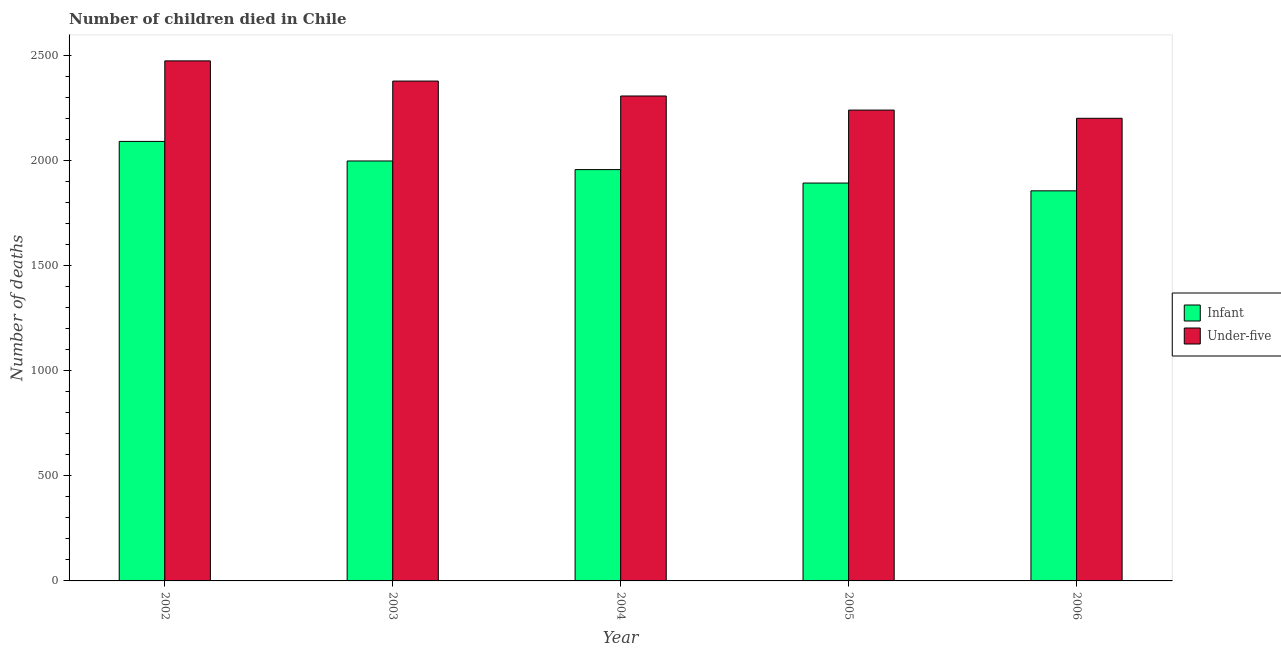How many different coloured bars are there?
Give a very brief answer. 2. Are the number of bars per tick equal to the number of legend labels?
Your answer should be compact. Yes. How many bars are there on the 5th tick from the left?
Your answer should be compact. 2. How many bars are there on the 4th tick from the right?
Ensure brevity in your answer.  2. In how many cases, is the number of bars for a given year not equal to the number of legend labels?
Provide a short and direct response. 0. What is the number of infant deaths in 2002?
Provide a short and direct response. 2090. Across all years, what is the maximum number of infant deaths?
Your answer should be compact. 2090. Across all years, what is the minimum number of under-five deaths?
Offer a terse response. 2200. In which year was the number of under-five deaths maximum?
Give a very brief answer. 2002. In which year was the number of infant deaths minimum?
Your response must be concise. 2006. What is the total number of infant deaths in the graph?
Your answer should be compact. 9790. What is the difference between the number of infant deaths in 2004 and that in 2006?
Your answer should be compact. 101. What is the difference between the number of under-five deaths in 2003 and the number of infant deaths in 2004?
Your answer should be compact. 71. What is the average number of under-five deaths per year?
Your response must be concise. 2319. In the year 2006, what is the difference between the number of under-five deaths and number of infant deaths?
Keep it short and to the point. 0. What is the ratio of the number of infant deaths in 2002 to that in 2004?
Provide a short and direct response. 1.07. Is the number of infant deaths in 2003 less than that in 2005?
Your response must be concise. No. Is the difference between the number of under-five deaths in 2002 and 2005 greater than the difference between the number of infant deaths in 2002 and 2005?
Your answer should be very brief. No. What is the difference between the highest and the second highest number of infant deaths?
Make the answer very short. 93. What is the difference between the highest and the lowest number of under-five deaths?
Offer a terse response. 273. In how many years, is the number of under-five deaths greater than the average number of under-five deaths taken over all years?
Provide a short and direct response. 2. Is the sum of the number of under-five deaths in 2003 and 2004 greater than the maximum number of infant deaths across all years?
Offer a terse response. Yes. What does the 2nd bar from the left in 2002 represents?
Make the answer very short. Under-five. What does the 2nd bar from the right in 2004 represents?
Offer a very short reply. Infant. How many bars are there?
Your answer should be very brief. 10. Are all the bars in the graph horizontal?
Your answer should be compact. No. How many years are there in the graph?
Offer a very short reply. 5. Does the graph contain grids?
Keep it short and to the point. No. Where does the legend appear in the graph?
Give a very brief answer. Center right. What is the title of the graph?
Your answer should be very brief. Number of children died in Chile. What is the label or title of the X-axis?
Offer a very short reply. Year. What is the label or title of the Y-axis?
Give a very brief answer. Number of deaths. What is the Number of deaths of Infant in 2002?
Provide a succinct answer. 2090. What is the Number of deaths of Under-five in 2002?
Make the answer very short. 2473. What is the Number of deaths in Infant in 2003?
Your answer should be compact. 1997. What is the Number of deaths in Under-five in 2003?
Your response must be concise. 2377. What is the Number of deaths in Infant in 2004?
Your answer should be compact. 1956. What is the Number of deaths in Under-five in 2004?
Provide a short and direct response. 2306. What is the Number of deaths in Infant in 2005?
Provide a short and direct response. 1892. What is the Number of deaths of Under-five in 2005?
Keep it short and to the point. 2239. What is the Number of deaths of Infant in 2006?
Provide a succinct answer. 1855. What is the Number of deaths in Under-five in 2006?
Offer a very short reply. 2200. Across all years, what is the maximum Number of deaths in Infant?
Keep it short and to the point. 2090. Across all years, what is the maximum Number of deaths of Under-five?
Keep it short and to the point. 2473. Across all years, what is the minimum Number of deaths in Infant?
Your answer should be very brief. 1855. Across all years, what is the minimum Number of deaths in Under-five?
Your answer should be very brief. 2200. What is the total Number of deaths in Infant in the graph?
Your response must be concise. 9790. What is the total Number of deaths in Under-five in the graph?
Keep it short and to the point. 1.16e+04. What is the difference between the Number of deaths in Infant in 2002 and that in 2003?
Ensure brevity in your answer.  93. What is the difference between the Number of deaths in Under-five in 2002 and that in 2003?
Offer a terse response. 96. What is the difference between the Number of deaths in Infant in 2002 and that in 2004?
Offer a terse response. 134. What is the difference between the Number of deaths of Under-five in 2002 and that in 2004?
Your response must be concise. 167. What is the difference between the Number of deaths of Infant in 2002 and that in 2005?
Keep it short and to the point. 198. What is the difference between the Number of deaths in Under-five in 2002 and that in 2005?
Offer a terse response. 234. What is the difference between the Number of deaths of Infant in 2002 and that in 2006?
Keep it short and to the point. 235. What is the difference between the Number of deaths in Under-five in 2002 and that in 2006?
Your answer should be very brief. 273. What is the difference between the Number of deaths of Infant in 2003 and that in 2004?
Offer a terse response. 41. What is the difference between the Number of deaths of Infant in 2003 and that in 2005?
Your answer should be compact. 105. What is the difference between the Number of deaths of Under-five in 2003 and that in 2005?
Keep it short and to the point. 138. What is the difference between the Number of deaths of Infant in 2003 and that in 2006?
Keep it short and to the point. 142. What is the difference between the Number of deaths in Under-five in 2003 and that in 2006?
Your answer should be very brief. 177. What is the difference between the Number of deaths in Infant in 2004 and that in 2006?
Make the answer very short. 101. What is the difference between the Number of deaths of Under-five in 2004 and that in 2006?
Provide a succinct answer. 106. What is the difference between the Number of deaths of Infant in 2005 and that in 2006?
Offer a terse response. 37. What is the difference between the Number of deaths of Infant in 2002 and the Number of deaths of Under-five in 2003?
Your answer should be compact. -287. What is the difference between the Number of deaths in Infant in 2002 and the Number of deaths in Under-five in 2004?
Your answer should be very brief. -216. What is the difference between the Number of deaths of Infant in 2002 and the Number of deaths of Under-five in 2005?
Provide a short and direct response. -149. What is the difference between the Number of deaths in Infant in 2002 and the Number of deaths in Under-five in 2006?
Your answer should be very brief. -110. What is the difference between the Number of deaths of Infant in 2003 and the Number of deaths of Under-five in 2004?
Your answer should be compact. -309. What is the difference between the Number of deaths in Infant in 2003 and the Number of deaths in Under-five in 2005?
Your response must be concise. -242. What is the difference between the Number of deaths of Infant in 2003 and the Number of deaths of Under-five in 2006?
Ensure brevity in your answer.  -203. What is the difference between the Number of deaths of Infant in 2004 and the Number of deaths of Under-five in 2005?
Give a very brief answer. -283. What is the difference between the Number of deaths in Infant in 2004 and the Number of deaths in Under-five in 2006?
Offer a very short reply. -244. What is the difference between the Number of deaths of Infant in 2005 and the Number of deaths of Under-five in 2006?
Provide a succinct answer. -308. What is the average Number of deaths of Infant per year?
Your response must be concise. 1958. What is the average Number of deaths in Under-five per year?
Keep it short and to the point. 2319. In the year 2002, what is the difference between the Number of deaths of Infant and Number of deaths of Under-five?
Give a very brief answer. -383. In the year 2003, what is the difference between the Number of deaths in Infant and Number of deaths in Under-five?
Provide a succinct answer. -380. In the year 2004, what is the difference between the Number of deaths in Infant and Number of deaths in Under-five?
Provide a succinct answer. -350. In the year 2005, what is the difference between the Number of deaths in Infant and Number of deaths in Under-five?
Give a very brief answer. -347. In the year 2006, what is the difference between the Number of deaths in Infant and Number of deaths in Under-five?
Your answer should be compact. -345. What is the ratio of the Number of deaths of Infant in 2002 to that in 2003?
Make the answer very short. 1.05. What is the ratio of the Number of deaths in Under-five in 2002 to that in 2003?
Offer a very short reply. 1.04. What is the ratio of the Number of deaths in Infant in 2002 to that in 2004?
Your answer should be very brief. 1.07. What is the ratio of the Number of deaths of Under-five in 2002 to that in 2004?
Keep it short and to the point. 1.07. What is the ratio of the Number of deaths of Infant in 2002 to that in 2005?
Provide a succinct answer. 1.1. What is the ratio of the Number of deaths of Under-five in 2002 to that in 2005?
Give a very brief answer. 1.1. What is the ratio of the Number of deaths in Infant in 2002 to that in 2006?
Your answer should be very brief. 1.13. What is the ratio of the Number of deaths of Under-five in 2002 to that in 2006?
Offer a very short reply. 1.12. What is the ratio of the Number of deaths in Under-five in 2003 to that in 2004?
Provide a short and direct response. 1.03. What is the ratio of the Number of deaths in Infant in 2003 to that in 2005?
Provide a short and direct response. 1.06. What is the ratio of the Number of deaths in Under-five in 2003 to that in 2005?
Ensure brevity in your answer.  1.06. What is the ratio of the Number of deaths in Infant in 2003 to that in 2006?
Provide a succinct answer. 1.08. What is the ratio of the Number of deaths in Under-five in 2003 to that in 2006?
Your response must be concise. 1.08. What is the ratio of the Number of deaths in Infant in 2004 to that in 2005?
Offer a terse response. 1.03. What is the ratio of the Number of deaths in Under-five in 2004 to that in 2005?
Provide a succinct answer. 1.03. What is the ratio of the Number of deaths in Infant in 2004 to that in 2006?
Make the answer very short. 1.05. What is the ratio of the Number of deaths in Under-five in 2004 to that in 2006?
Your answer should be compact. 1.05. What is the ratio of the Number of deaths of Infant in 2005 to that in 2006?
Ensure brevity in your answer.  1.02. What is the ratio of the Number of deaths in Under-five in 2005 to that in 2006?
Your response must be concise. 1.02. What is the difference between the highest and the second highest Number of deaths in Infant?
Your answer should be compact. 93. What is the difference between the highest and the second highest Number of deaths of Under-five?
Offer a very short reply. 96. What is the difference between the highest and the lowest Number of deaths of Infant?
Provide a succinct answer. 235. What is the difference between the highest and the lowest Number of deaths of Under-five?
Offer a very short reply. 273. 